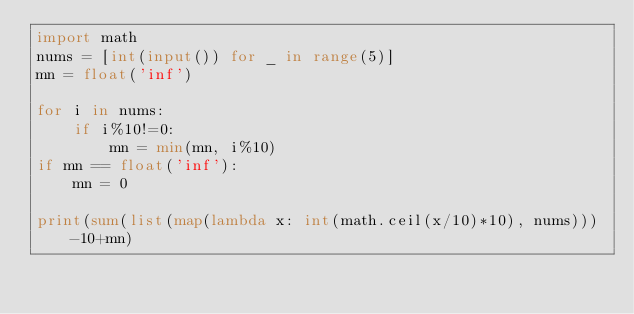Convert code to text. <code><loc_0><loc_0><loc_500><loc_500><_Python_>import math
nums = [int(input()) for _ in range(5)]
mn = float('inf')

for i in nums:
    if i%10!=0:
        mn = min(mn, i%10)
if mn == float('inf'):
    mn = 0

print(sum(list(map(lambda x: int(math.ceil(x/10)*10), nums)))-10+mn)
</code> 